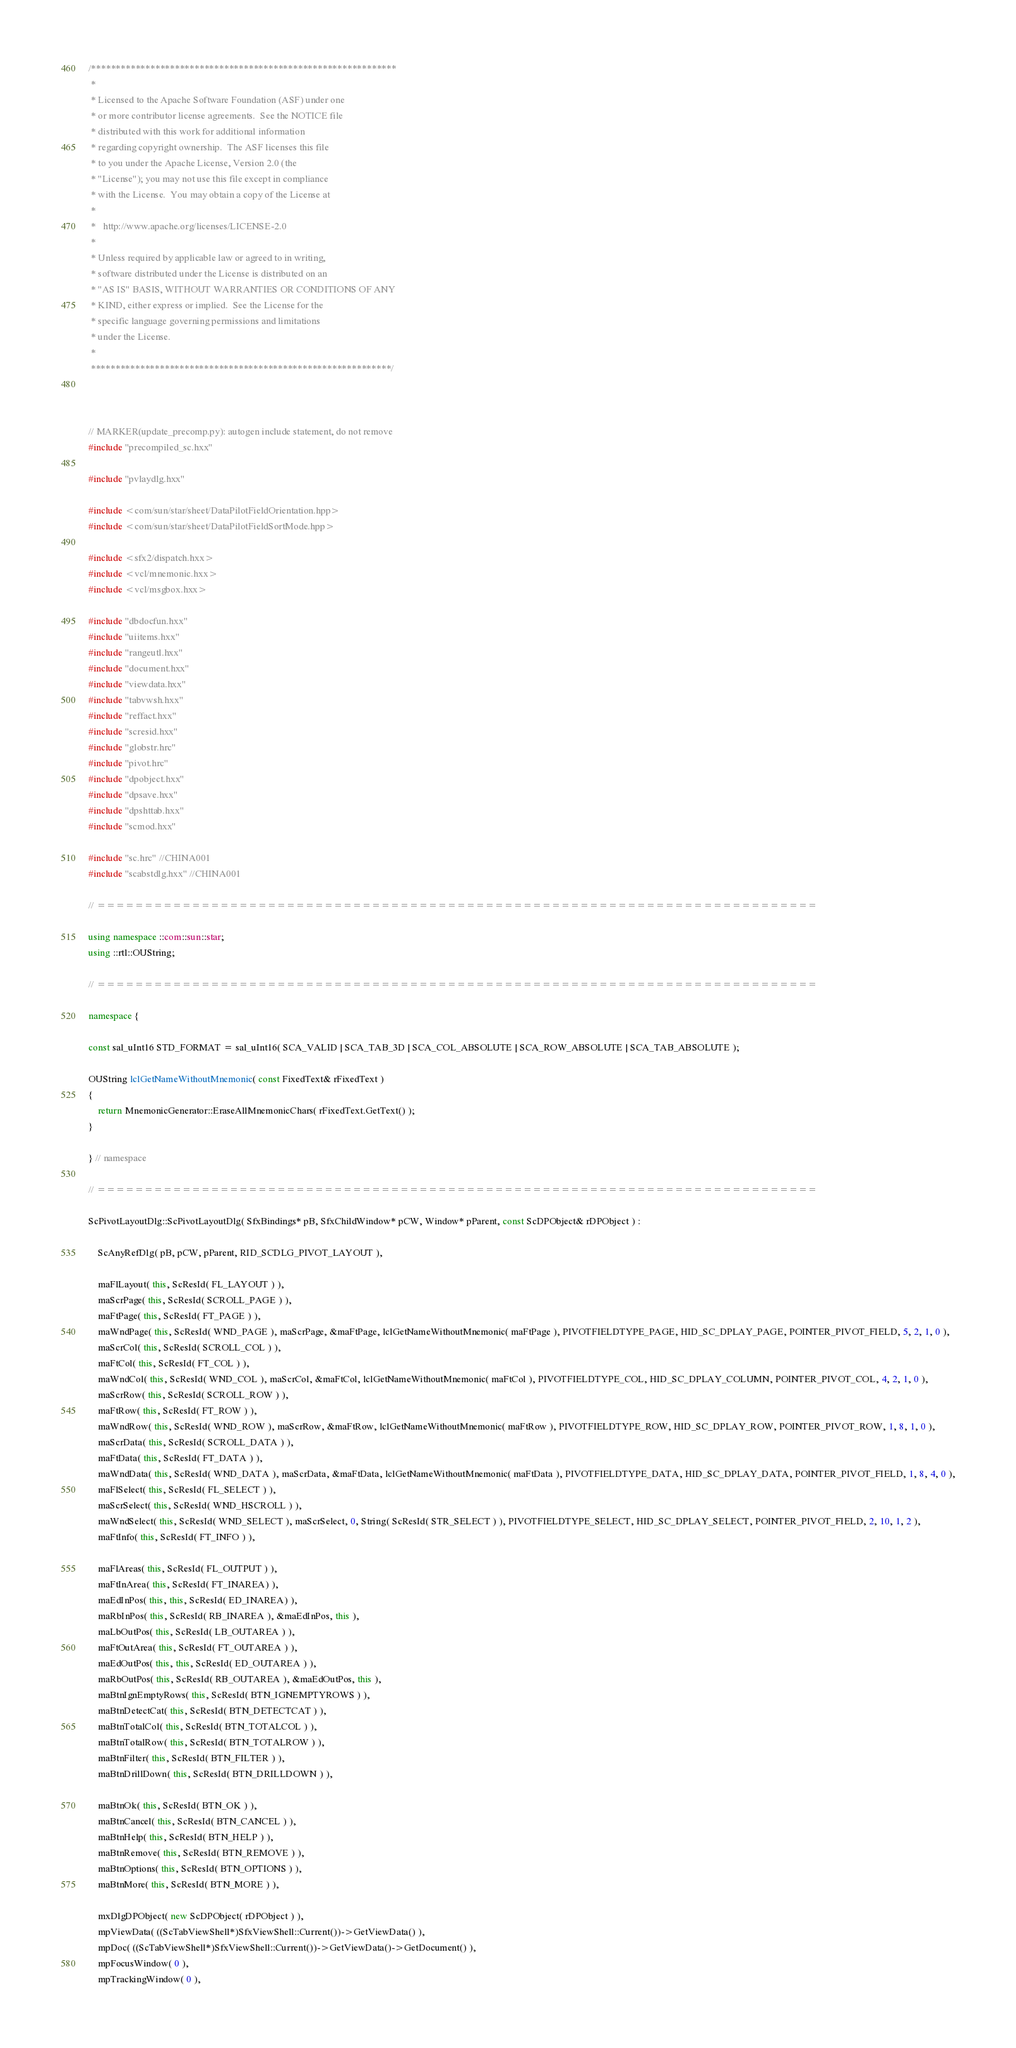Convert code to text. <code><loc_0><loc_0><loc_500><loc_500><_C++_>/**************************************************************
 * 
 * Licensed to the Apache Software Foundation (ASF) under one
 * or more contributor license agreements.  See the NOTICE file
 * distributed with this work for additional information
 * regarding copyright ownership.  The ASF licenses this file
 * to you under the Apache License, Version 2.0 (the
 * "License"); you may not use this file except in compliance
 * with the License.  You may obtain a copy of the License at
 * 
 *   http://www.apache.org/licenses/LICENSE-2.0
 * 
 * Unless required by applicable law or agreed to in writing,
 * software distributed under the License is distributed on an
 * "AS IS" BASIS, WITHOUT WARRANTIES OR CONDITIONS OF ANY
 * KIND, either express or implied.  See the License for the
 * specific language governing permissions and limitations
 * under the License.
 * 
 *************************************************************/



// MARKER(update_precomp.py): autogen include statement, do not remove
#include "precompiled_sc.hxx"

#include "pvlaydlg.hxx"

#include <com/sun/star/sheet/DataPilotFieldOrientation.hpp>
#include <com/sun/star/sheet/DataPilotFieldSortMode.hpp>

#include <sfx2/dispatch.hxx>
#include <vcl/mnemonic.hxx>
#include <vcl/msgbox.hxx>

#include "dbdocfun.hxx"
#include "uiitems.hxx"
#include "rangeutl.hxx"
#include "document.hxx"
#include "viewdata.hxx"
#include "tabvwsh.hxx"
#include "reffact.hxx"
#include "scresid.hxx"
#include "globstr.hrc"
#include "pivot.hrc"
#include "dpobject.hxx"
#include "dpsave.hxx"
#include "dpshttab.hxx"
#include "scmod.hxx"

#include "sc.hrc" //CHINA001
#include "scabstdlg.hxx" //CHINA001

// ============================================================================

using namespace ::com::sun::star;
using ::rtl::OUString;

// ============================================================================

namespace {

const sal_uInt16 STD_FORMAT = sal_uInt16( SCA_VALID | SCA_TAB_3D | SCA_COL_ABSOLUTE | SCA_ROW_ABSOLUTE | SCA_TAB_ABSOLUTE );

OUString lclGetNameWithoutMnemonic( const FixedText& rFixedText )
{
    return MnemonicGenerator::EraseAllMnemonicChars( rFixedText.GetText() );
}

} // namespace

// ============================================================================

ScPivotLayoutDlg::ScPivotLayoutDlg( SfxBindings* pB, SfxChildWindow* pCW, Window* pParent, const ScDPObject& rDPObject ) :

	ScAnyRefDlg( pB, pCW, pParent, RID_SCDLG_PIVOT_LAYOUT ),

    maFlLayout( this, ScResId( FL_LAYOUT ) ),
	maScrPage( this, ScResId( SCROLL_PAGE ) ),
    maFtPage( this, ScResId( FT_PAGE ) ),
    maWndPage( this, ScResId( WND_PAGE ), maScrPage, &maFtPage, lclGetNameWithoutMnemonic( maFtPage ), PIVOTFIELDTYPE_PAGE, HID_SC_DPLAY_PAGE, POINTER_PIVOT_FIELD, 5, 2, 1, 0 ),
	maScrCol( this, ScResId( SCROLL_COL ) ),
    maFtCol( this, ScResId( FT_COL ) ),
    maWndCol( this, ScResId( WND_COL ), maScrCol, &maFtCol, lclGetNameWithoutMnemonic( maFtCol ), PIVOTFIELDTYPE_COL, HID_SC_DPLAY_COLUMN, POINTER_PIVOT_COL, 4, 2, 1, 0 ),
	maScrRow( this, ScResId( SCROLL_ROW ) ),
    maFtRow( this, ScResId( FT_ROW ) ),
    maWndRow( this, ScResId( WND_ROW ), maScrRow, &maFtRow, lclGetNameWithoutMnemonic( maFtRow ), PIVOTFIELDTYPE_ROW, HID_SC_DPLAY_ROW, POINTER_PIVOT_ROW, 1, 8, 1, 0 ),
	maScrData( this, ScResId( SCROLL_DATA ) ),
    maFtData( this, ScResId( FT_DATA ) ),
    maWndData( this, ScResId( WND_DATA ), maScrData, &maFtData, lclGetNameWithoutMnemonic( maFtData ), PIVOTFIELDTYPE_DATA, HID_SC_DPLAY_DATA, POINTER_PIVOT_FIELD, 1, 8, 4, 0 ),
    maFlSelect( this, ScResId( FL_SELECT ) ),
	maScrSelect( this, ScResId( WND_HSCROLL ) ),
    maWndSelect( this, ScResId( WND_SELECT ), maScrSelect, 0, String( ScResId( STR_SELECT ) ), PIVOTFIELDTYPE_SELECT, HID_SC_DPLAY_SELECT, POINTER_PIVOT_FIELD, 2, 10, 1, 2 ),
	maFtInfo( this, ScResId( FT_INFO ) ),

    maFlAreas( this, ScResId( FL_OUTPUT ) ),
    maFtInArea( this, ScResId( FT_INAREA) ),
    maEdInPos( this, this, ScResId( ED_INAREA) ),
    maRbInPos( this, ScResId( RB_INAREA ), &maEdInPos, this ),
	maLbOutPos( this, ScResId( LB_OUTAREA ) ),
	maFtOutArea( this, ScResId( FT_OUTAREA ) ),
    maEdOutPos( this, this, ScResId( ED_OUTAREA ) ),
	maRbOutPos( this, ScResId( RB_OUTAREA ), &maEdOutPos, this ),
	maBtnIgnEmptyRows( this, ScResId( BTN_IGNEMPTYROWS ) ),
	maBtnDetectCat( this, ScResId( BTN_DETECTCAT ) ),
	maBtnTotalCol( this, ScResId( BTN_TOTALCOL ) ),
	maBtnTotalRow( this, ScResId( BTN_TOTALROW ) ),
    maBtnFilter( this, ScResId( BTN_FILTER ) ),
    maBtnDrillDown( this, ScResId( BTN_DRILLDOWN ) ),

	maBtnOk( this, ScResId( BTN_OK ) ),
	maBtnCancel( this, ScResId( BTN_CANCEL ) ),
	maBtnHelp( this, ScResId( BTN_HELP ) ),
    maBtnRemove( this, ScResId( BTN_REMOVE ) ),
    maBtnOptions( this, ScResId( BTN_OPTIONS ) ),
	maBtnMore( this, ScResId( BTN_MORE ) ),

    mxDlgDPObject( new ScDPObject( rDPObject ) ),
	mpViewData( ((ScTabViewShell*)SfxViewShell::Current())->GetViewData() ),
	mpDoc( ((ScTabViewShell*)SfxViewShell::Current())->GetViewData()->GetDocument() ),
	mpFocusWindow( 0 ),
	mpTrackingWindow( 0 ),</code> 